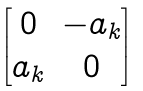<formula> <loc_0><loc_0><loc_500><loc_500>\begin{bmatrix} 0 & - a _ { k } \\ a _ { k } & 0 \end{bmatrix}</formula> 